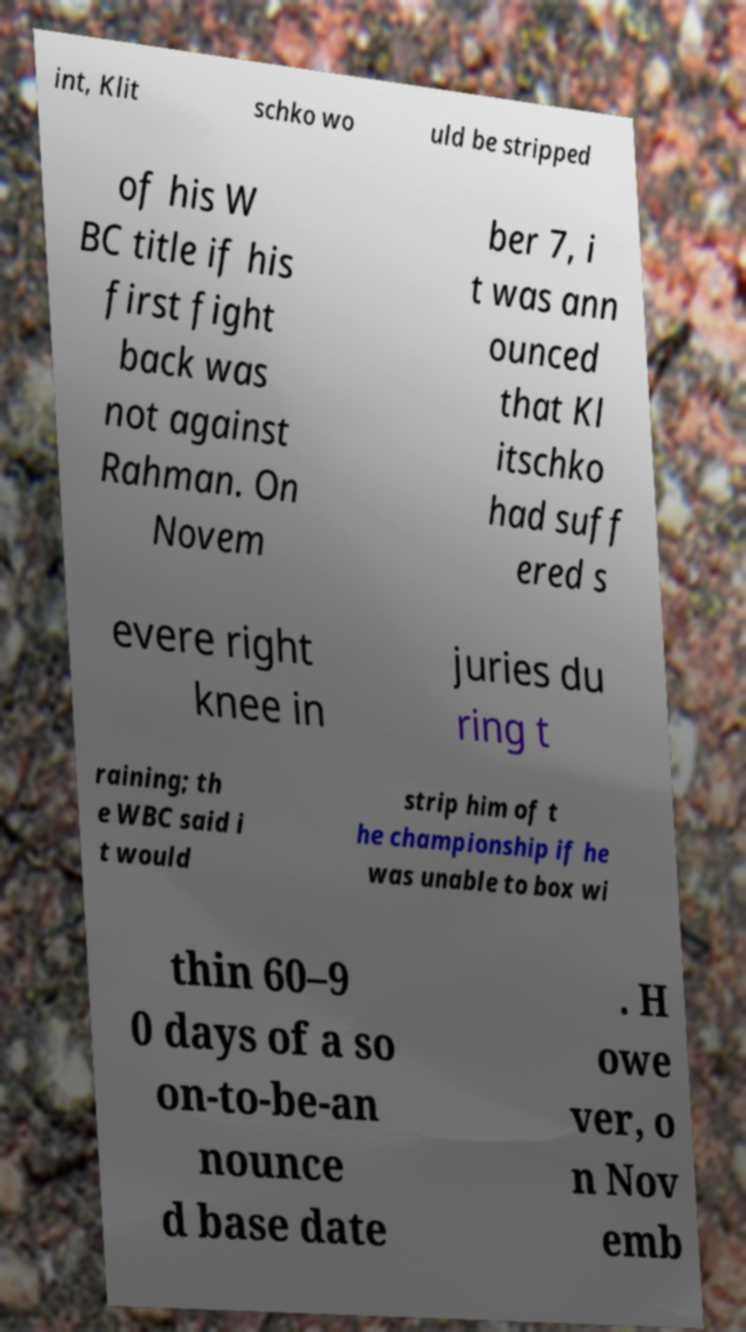Can you accurately transcribe the text from the provided image for me? int, Klit schko wo uld be stripped of his W BC title if his first fight back was not against Rahman. On Novem ber 7, i t was ann ounced that Kl itschko had suff ered s evere right knee in juries du ring t raining; th e WBC said i t would strip him of t he championship if he was unable to box wi thin 60–9 0 days of a so on-to-be-an nounce d base date . H owe ver, o n Nov emb 